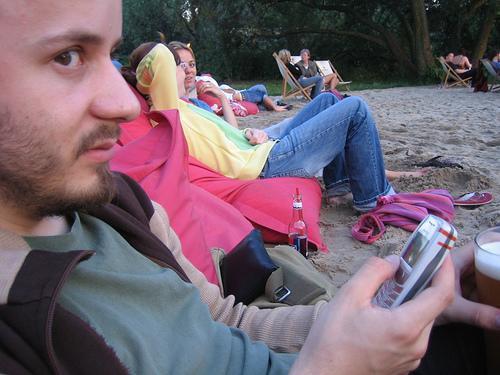What kind of ground are these people sitting on?
From the following set of four choices, select the accurate answer to respond to the question.
Options: Ash, sand, marble, concrete. Sand. 